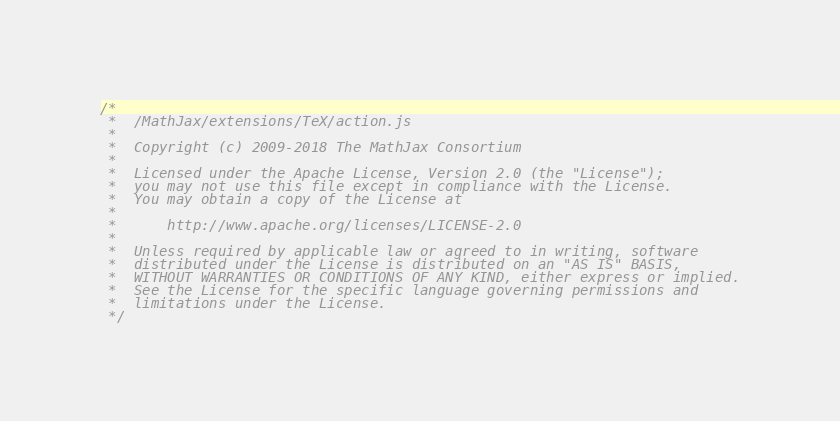<code> <loc_0><loc_0><loc_500><loc_500><_JavaScript_>/*
 *  /MathJax/extensions/TeX/action.js
 *
 *  Copyright (c) 2009-2018 The MathJax Consortium
 *
 *  Licensed under the Apache License, Version 2.0 (the "License");
 *  you may not use this file except in compliance with the License.
 *  You may obtain a copy of the License at
 *
 *      http://www.apache.org/licenses/LICENSE-2.0
 *
 *  Unless required by applicable law or agreed to in writing, software
 *  distributed under the License is distributed on an "AS IS" BASIS,
 *  WITHOUT WARRANTIES OR CONDITIONS OF ANY KIND, either express or implied.
 *  See the License for the specific language governing permissions and
 *  limitations under the License.
 */
</code> 